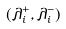Convert formula to latex. <formula><loc_0><loc_0><loc_500><loc_500>( \lambda _ { i } ^ { + } , \lambda _ { i } ^ { - } )</formula> 